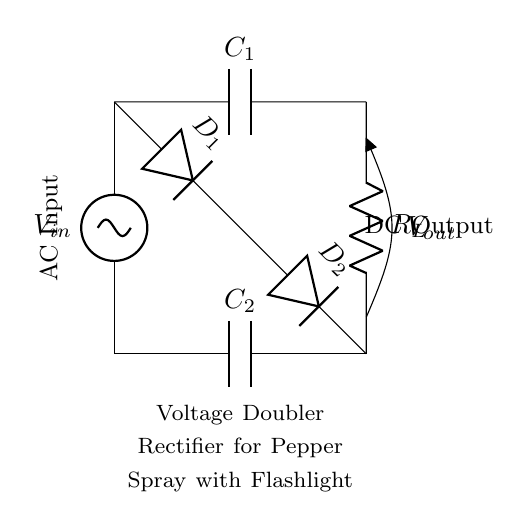What is the type of circuit shown? The circuit is a voltage doubler rectifier, which is indicated by the presence of capacitors and diodes arranged to double the input voltage.
Answer: Voltage doubler rectifier How many capacitors are present in the circuit? There are two capacitors, marked as C1 and C2, shown in the diagram connected to the AC source and the output.
Answer: Two What components are used for rectification in this circuit? The components used for rectification are two diodes labeled D1 and D2, as they allow current to flow in only one direction and are essential for converting AC to DC.
Answer: Two diodes What is the function of load resistor R_L? The load resistor R_L is used to regulate the current flowing to the output and simulate a load for the circuit. Its presence provides a path for current and is essential for the output voltage measurement.
Answer: Regulate current Which part of the circuit indicates the output voltage? The output voltage is indicated at the points connected to V_out, which is the voltage across the load resistor R_L. This output is what will power the flashlight and the pepper spray.
Answer: V_out How does this circuit achieve voltage doubling? The voltage doubling is achieved through the combination of the two capacitors and two diodes; during separate halves of the AC cycle, each capacitor charges to the peak voltage, and when combined, they effectively double the output voltage.
Answer: Capacitors and diodes What is the input voltage denoted in the diagram? The input voltage is denoted by V_in, located at the top left of the circuit and represents the voltage from the AC source feeding into the system.
Answer: V_in 